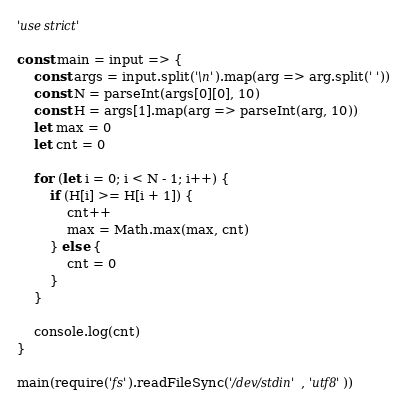<code> <loc_0><loc_0><loc_500><loc_500><_JavaScript_>'use strict'

const main = input => {
	const args = input.split('\n').map(arg => arg.split(' '))
	const N = parseInt(args[0][0], 10)
	const H = args[1].map(arg => parseInt(arg, 10))
	let max = 0
	let cnt = 0
	
	for (let i = 0; i < N - 1; i++) {
		if (H[i] >= H[i + 1]) {
			cnt++
			max = Math.max(max, cnt)
		} else {
			cnt = 0
		}
	}

	console.log(cnt)
}

main(require('fs').readFileSync('/dev/stdin', 'utf8'))
</code> 